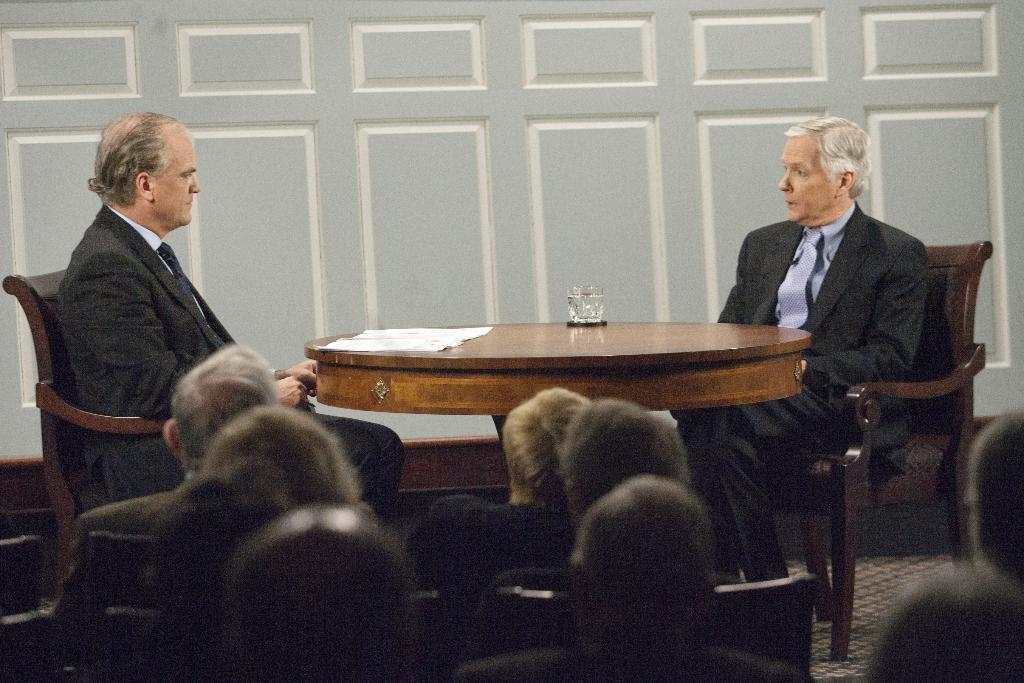What is the person in the image doing? The person is sitting on a chair. What is in front of the chair? There is a table in front of the chair. What is on the table? There is a glass on the table. Are there any other people in the image? Yes, there is a group of people sitting nearby. What road is the person planning to smash with the committee in the image? There is no road, committee, or smashing activity present in the image. 